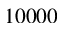<formula> <loc_0><loc_0><loc_500><loc_500>1 0 0 0 0</formula> 